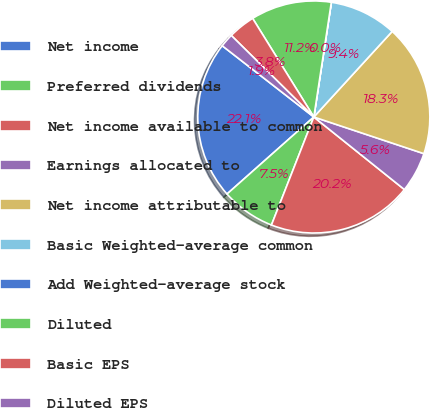Convert chart. <chart><loc_0><loc_0><loc_500><loc_500><pie_chart><fcel>Net income<fcel>Preferred dividends<fcel>Net income available to common<fcel>Earnings allocated to<fcel>Net income attributable to<fcel>Basic Weighted-average common<fcel>Add Weighted-average stock<fcel>Diluted<fcel>Basic EPS<fcel>Diluted EPS<nl><fcel>22.07%<fcel>7.5%<fcel>20.2%<fcel>5.63%<fcel>18.32%<fcel>9.38%<fcel>0.01%<fcel>11.25%<fcel>3.76%<fcel>1.88%<nl></chart> 